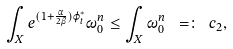<formula> <loc_0><loc_0><loc_500><loc_500>\int _ { X } e ^ { ( 1 + \frac { \alpha } { 2 \beta } ) \varphi _ { t } ^ { \ast } } \omega _ { 0 } ^ { n } \leq \int _ { X } \omega _ { 0 } ^ { n } \ = \colon \ c _ { 2 } ,</formula> 